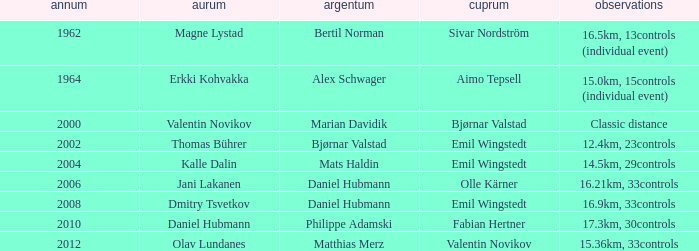WHAT YEAR HAS A BRONZE OF VALENTIN NOVIKOV? 2012.0. 